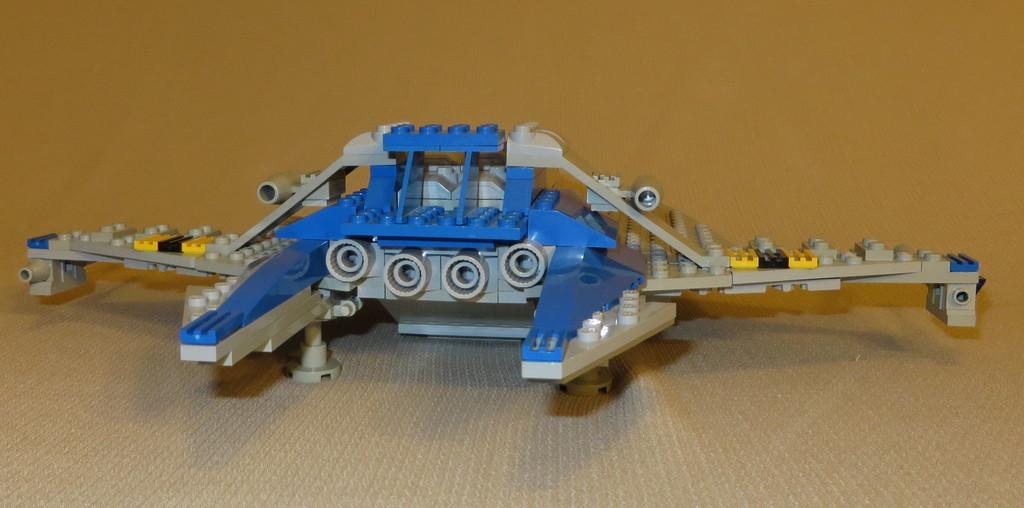Could you give a brief overview of what you see in this image? In the center of the image there is a lego toy. At the bottom of the image there is carpet. 